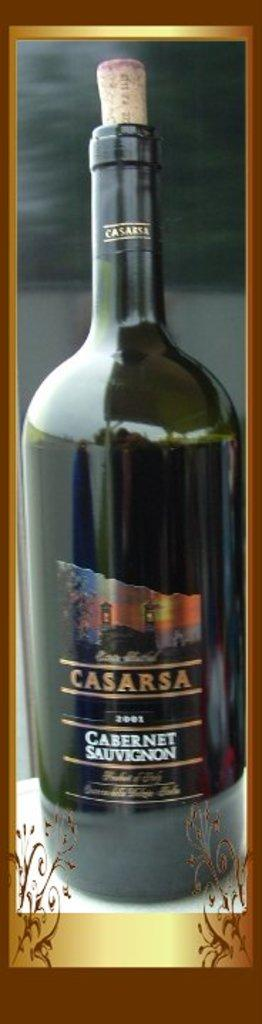<image>
Present a compact description of the photo's key features. Bottle of Casarsa wine is sitting on the window sill. 